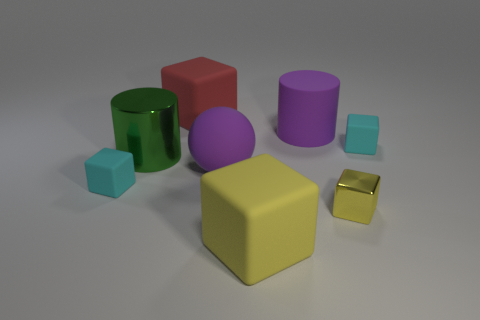Subtract all gray cubes. Subtract all blue spheres. How many cubes are left? 5 Add 1 big red objects. How many objects exist? 9 Subtract all spheres. How many objects are left? 7 Subtract 0 blue cubes. How many objects are left? 8 Subtract all large yellow things. Subtract all large blocks. How many objects are left? 5 Add 6 small rubber blocks. How many small rubber blocks are left? 8 Add 1 yellow things. How many yellow things exist? 3 